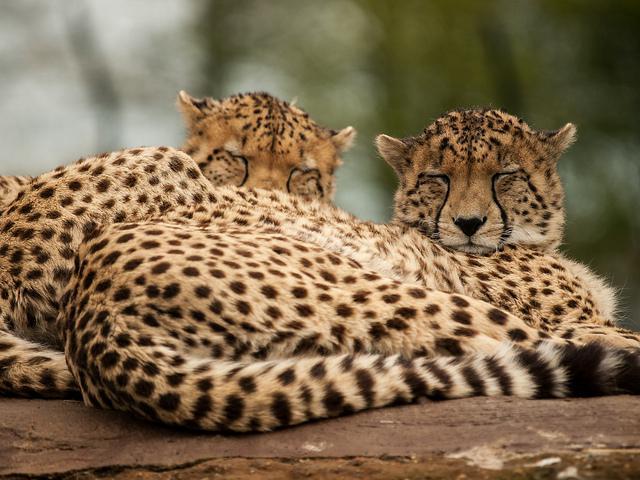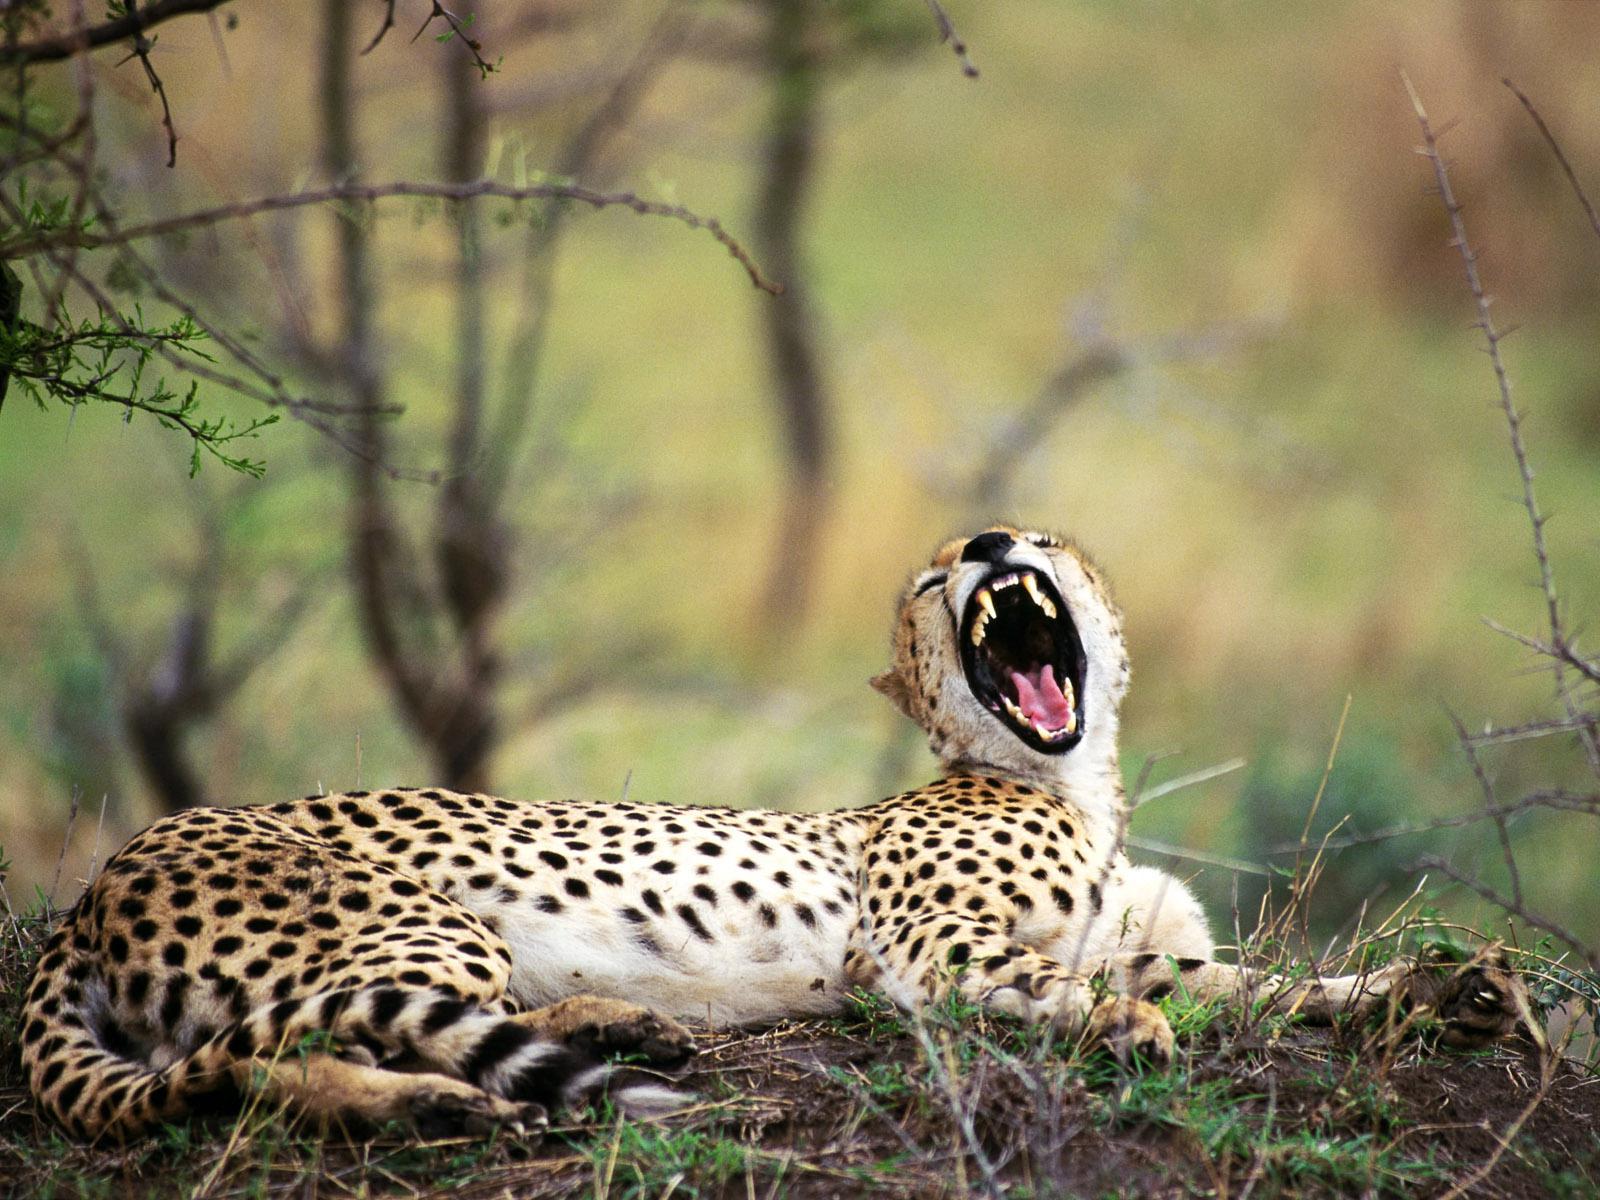The first image is the image on the left, the second image is the image on the right. Given the left and right images, does the statement "A larger spotted wild cat is extending its neck and head toward the head of a smaller spotted wild cat." hold true? Answer yes or no. No. 